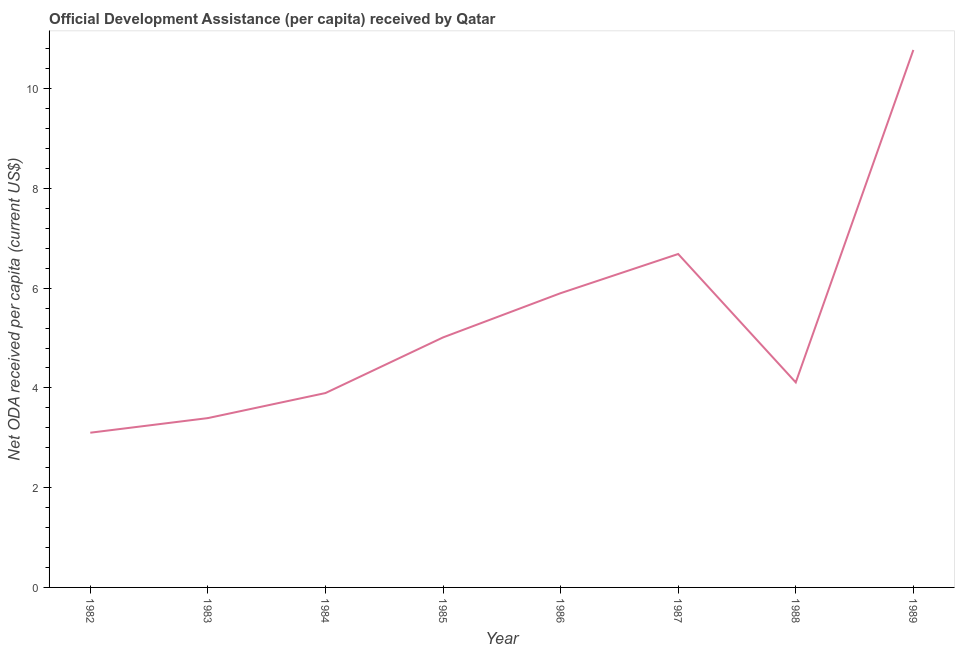What is the net oda received per capita in 1984?
Provide a succinct answer. 3.9. Across all years, what is the maximum net oda received per capita?
Give a very brief answer. 10.78. Across all years, what is the minimum net oda received per capita?
Offer a very short reply. 3.1. In which year was the net oda received per capita minimum?
Provide a short and direct response. 1982. What is the sum of the net oda received per capita?
Provide a short and direct response. 42.88. What is the difference between the net oda received per capita in 1983 and 1984?
Your answer should be compact. -0.5. What is the average net oda received per capita per year?
Your answer should be compact. 5.36. What is the median net oda received per capita?
Your answer should be very brief. 4.56. Do a majority of the years between 1982 and 1987 (inclusive) have net oda received per capita greater than 1.2000000000000002 US$?
Your answer should be very brief. Yes. What is the ratio of the net oda received per capita in 1982 to that in 1986?
Your answer should be very brief. 0.53. Is the net oda received per capita in 1983 less than that in 1985?
Offer a very short reply. Yes. Is the difference between the net oda received per capita in 1982 and 1983 greater than the difference between any two years?
Offer a terse response. No. What is the difference between the highest and the second highest net oda received per capita?
Provide a short and direct response. 4.09. What is the difference between the highest and the lowest net oda received per capita?
Your response must be concise. 7.67. In how many years, is the net oda received per capita greater than the average net oda received per capita taken over all years?
Provide a succinct answer. 3. Does the net oda received per capita monotonically increase over the years?
Your answer should be compact. No. How many years are there in the graph?
Provide a short and direct response. 8. Are the values on the major ticks of Y-axis written in scientific E-notation?
Offer a very short reply. No. Does the graph contain any zero values?
Offer a terse response. No. What is the title of the graph?
Keep it short and to the point. Official Development Assistance (per capita) received by Qatar. What is the label or title of the Y-axis?
Make the answer very short. Net ODA received per capita (current US$). What is the Net ODA received per capita (current US$) of 1982?
Offer a very short reply. 3.1. What is the Net ODA received per capita (current US$) of 1983?
Your response must be concise. 3.4. What is the Net ODA received per capita (current US$) in 1984?
Your answer should be very brief. 3.9. What is the Net ODA received per capita (current US$) of 1985?
Your response must be concise. 5.01. What is the Net ODA received per capita (current US$) of 1986?
Make the answer very short. 5.9. What is the Net ODA received per capita (current US$) of 1987?
Your answer should be very brief. 6.69. What is the Net ODA received per capita (current US$) in 1988?
Make the answer very short. 4.11. What is the Net ODA received per capita (current US$) in 1989?
Keep it short and to the point. 10.78. What is the difference between the Net ODA received per capita (current US$) in 1982 and 1983?
Keep it short and to the point. -0.29. What is the difference between the Net ODA received per capita (current US$) in 1982 and 1984?
Your response must be concise. -0.8. What is the difference between the Net ODA received per capita (current US$) in 1982 and 1985?
Ensure brevity in your answer.  -1.91. What is the difference between the Net ODA received per capita (current US$) in 1982 and 1986?
Give a very brief answer. -2.8. What is the difference between the Net ODA received per capita (current US$) in 1982 and 1987?
Your response must be concise. -3.58. What is the difference between the Net ODA received per capita (current US$) in 1982 and 1988?
Your answer should be compact. -1.01. What is the difference between the Net ODA received per capita (current US$) in 1982 and 1989?
Make the answer very short. -7.67. What is the difference between the Net ODA received per capita (current US$) in 1983 and 1984?
Keep it short and to the point. -0.5. What is the difference between the Net ODA received per capita (current US$) in 1983 and 1985?
Offer a very short reply. -1.62. What is the difference between the Net ODA received per capita (current US$) in 1983 and 1986?
Provide a short and direct response. -2.5. What is the difference between the Net ODA received per capita (current US$) in 1983 and 1987?
Offer a very short reply. -3.29. What is the difference between the Net ODA received per capita (current US$) in 1983 and 1988?
Your answer should be very brief. -0.72. What is the difference between the Net ODA received per capita (current US$) in 1983 and 1989?
Your answer should be compact. -7.38. What is the difference between the Net ODA received per capita (current US$) in 1984 and 1985?
Your response must be concise. -1.12. What is the difference between the Net ODA received per capita (current US$) in 1984 and 1986?
Provide a succinct answer. -2. What is the difference between the Net ODA received per capita (current US$) in 1984 and 1987?
Your answer should be compact. -2.79. What is the difference between the Net ODA received per capita (current US$) in 1984 and 1988?
Your answer should be compact. -0.21. What is the difference between the Net ODA received per capita (current US$) in 1984 and 1989?
Offer a very short reply. -6.88. What is the difference between the Net ODA received per capita (current US$) in 1985 and 1986?
Ensure brevity in your answer.  -0.89. What is the difference between the Net ODA received per capita (current US$) in 1985 and 1987?
Your response must be concise. -1.67. What is the difference between the Net ODA received per capita (current US$) in 1985 and 1988?
Your response must be concise. 0.9. What is the difference between the Net ODA received per capita (current US$) in 1985 and 1989?
Make the answer very short. -5.76. What is the difference between the Net ODA received per capita (current US$) in 1986 and 1987?
Ensure brevity in your answer.  -0.79. What is the difference between the Net ODA received per capita (current US$) in 1986 and 1988?
Give a very brief answer. 1.79. What is the difference between the Net ODA received per capita (current US$) in 1986 and 1989?
Your answer should be compact. -4.88. What is the difference between the Net ODA received per capita (current US$) in 1987 and 1988?
Ensure brevity in your answer.  2.57. What is the difference between the Net ODA received per capita (current US$) in 1987 and 1989?
Offer a very short reply. -4.09. What is the difference between the Net ODA received per capita (current US$) in 1988 and 1989?
Provide a succinct answer. -6.67. What is the ratio of the Net ODA received per capita (current US$) in 1982 to that in 1983?
Offer a very short reply. 0.91. What is the ratio of the Net ODA received per capita (current US$) in 1982 to that in 1984?
Ensure brevity in your answer.  0.8. What is the ratio of the Net ODA received per capita (current US$) in 1982 to that in 1985?
Your answer should be very brief. 0.62. What is the ratio of the Net ODA received per capita (current US$) in 1982 to that in 1986?
Ensure brevity in your answer.  0.53. What is the ratio of the Net ODA received per capita (current US$) in 1982 to that in 1987?
Your response must be concise. 0.46. What is the ratio of the Net ODA received per capita (current US$) in 1982 to that in 1988?
Offer a very short reply. 0.76. What is the ratio of the Net ODA received per capita (current US$) in 1982 to that in 1989?
Make the answer very short. 0.29. What is the ratio of the Net ODA received per capita (current US$) in 1983 to that in 1984?
Your answer should be very brief. 0.87. What is the ratio of the Net ODA received per capita (current US$) in 1983 to that in 1985?
Provide a short and direct response. 0.68. What is the ratio of the Net ODA received per capita (current US$) in 1983 to that in 1986?
Keep it short and to the point. 0.57. What is the ratio of the Net ODA received per capita (current US$) in 1983 to that in 1987?
Keep it short and to the point. 0.51. What is the ratio of the Net ODA received per capita (current US$) in 1983 to that in 1988?
Your response must be concise. 0.83. What is the ratio of the Net ODA received per capita (current US$) in 1983 to that in 1989?
Your answer should be compact. 0.32. What is the ratio of the Net ODA received per capita (current US$) in 1984 to that in 1985?
Your answer should be very brief. 0.78. What is the ratio of the Net ODA received per capita (current US$) in 1984 to that in 1986?
Provide a short and direct response. 0.66. What is the ratio of the Net ODA received per capita (current US$) in 1984 to that in 1987?
Provide a succinct answer. 0.58. What is the ratio of the Net ODA received per capita (current US$) in 1984 to that in 1988?
Your response must be concise. 0.95. What is the ratio of the Net ODA received per capita (current US$) in 1984 to that in 1989?
Give a very brief answer. 0.36. What is the ratio of the Net ODA received per capita (current US$) in 1985 to that in 1988?
Your answer should be very brief. 1.22. What is the ratio of the Net ODA received per capita (current US$) in 1985 to that in 1989?
Offer a very short reply. 0.47. What is the ratio of the Net ODA received per capita (current US$) in 1986 to that in 1987?
Your response must be concise. 0.88. What is the ratio of the Net ODA received per capita (current US$) in 1986 to that in 1988?
Keep it short and to the point. 1.44. What is the ratio of the Net ODA received per capita (current US$) in 1986 to that in 1989?
Give a very brief answer. 0.55. What is the ratio of the Net ODA received per capita (current US$) in 1987 to that in 1988?
Provide a short and direct response. 1.63. What is the ratio of the Net ODA received per capita (current US$) in 1987 to that in 1989?
Your answer should be very brief. 0.62. What is the ratio of the Net ODA received per capita (current US$) in 1988 to that in 1989?
Provide a succinct answer. 0.38. 